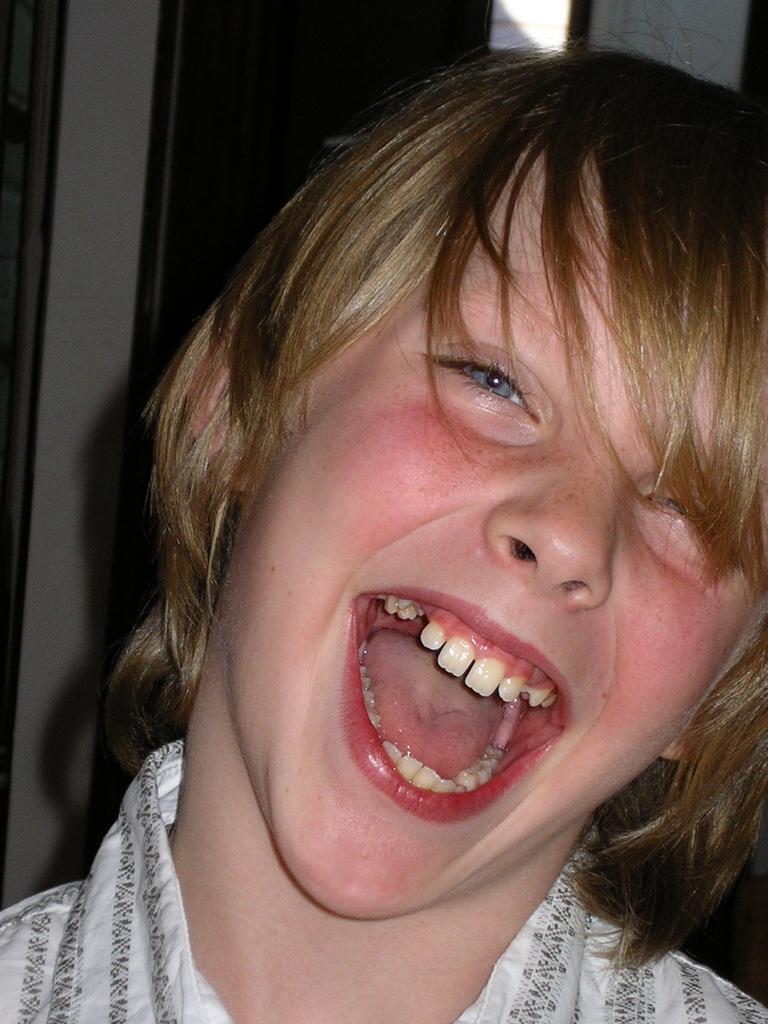How would you summarize this image in a sentence or two? In this image we can see a person smiling. In the background there is a door. 